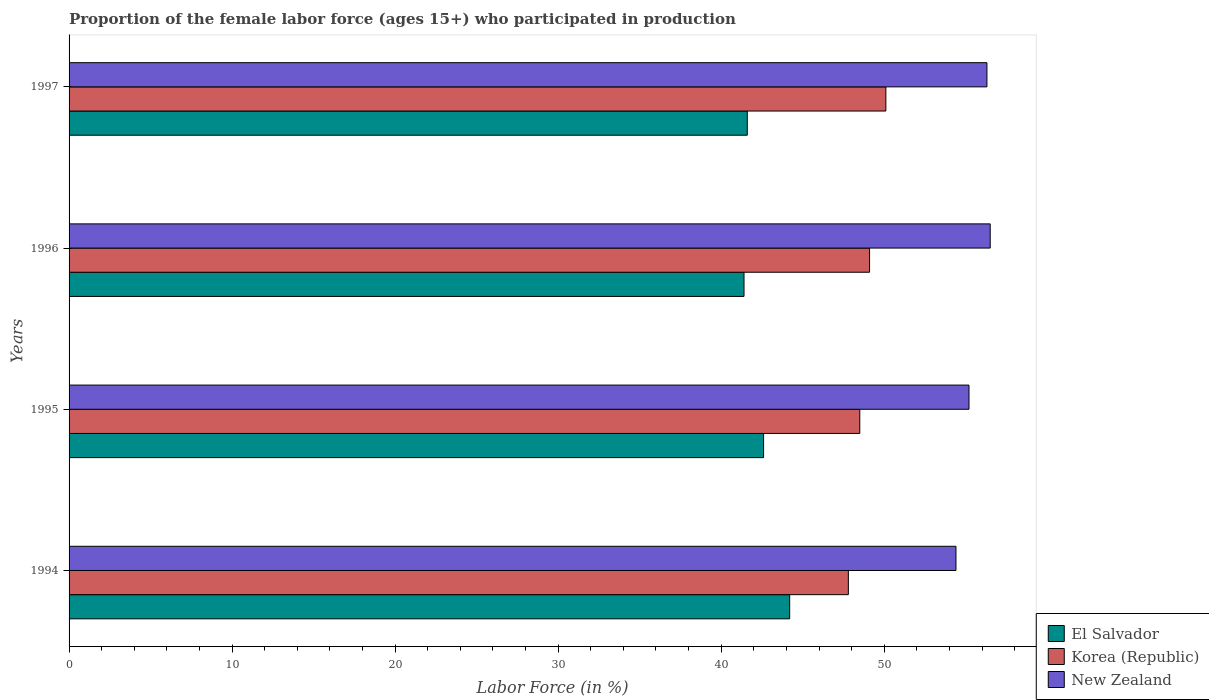How many groups of bars are there?
Make the answer very short. 4. What is the label of the 2nd group of bars from the top?
Provide a succinct answer. 1996. In how many cases, is the number of bars for a given year not equal to the number of legend labels?
Make the answer very short. 0. What is the proportion of the female labor force who participated in production in El Salvador in 1997?
Your answer should be compact. 41.6. Across all years, what is the maximum proportion of the female labor force who participated in production in New Zealand?
Provide a succinct answer. 56.5. Across all years, what is the minimum proportion of the female labor force who participated in production in El Salvador?
Keep it short and to the point. 41.4. In which year was the proportion of the female labor force who participated in production in El Salvador minimum?
Provide a succinct answer. 1996. What is the total proportion of the female labor force who participated in production in El Salvador in the graph?
Your answer should be compact. 169.8. What is the difference between the proportion of the female labor force who participated in production in El Salvador in 1995 and that in 1996?
Make the answer very short. 1.2. What is the difference between the proportion of the female labor force who participated in production in New Zealand in 1995 and the proportion of the female labor force who participated in production in Korea (Republic) in 1997?
Give a very brief answer. 5.1. What is the average proportion of the female labor force who participated in production in New Zealand per year?
Your answer should be very brief. 55.6. In the year 1996, what is the difference between the proportion of the female labor force who participated in production in Korea (Republic) and proportion of the female labor force who participated in production in New Zealand?
Ensure brevity in your answer.  -7.4. In how many years, is the proportion of the female labor force who participated in production in New Zealand greater than 20 %?
Provide a short and direct response. 4. What is the ratio of the proportion of the female labor force who participated in production in New Zealand in 1995 to that in 1996?
Your response must be concise. 0.98. What is the difference between the highest and the second highest proportion of the female labor force who participated in production in Korea (Republic)?
Offer a very short reply. 1. What is the difference between the highest and the lowest proportion of the female labor force who participated in production in New Zealand?
Ensure brevity in your answer.  2.1. In how many years, is the proportion of the female labor force who participated in production in Korea (Republic) greater than the average proportion of the female labor force who participated in production in Korea (Republic) taken over all years?
Your response must be concise. 2. What does the 3rd bar from the top in 1995 represents?
Provide a short and direct response. El Salvador. What does the 3rd bar from the bottom in 1995 represents?
Provide a succinct answer. New Zealand. Is it the case that in every year, the sum of the proportion of the female labor force who participated in production in Korea (Republic) and proportion of the female labor force who participated in production in New Zealand is greater than the proportion of the female labor force who participated in production in El Salvador?
Provide a short and direct response. Yes. Are all the bars in the graph horizontal?
Make the answer very short. Yes. How many years are there in the graph?
Your answer should be compact. 4. Are the values on the major ticks of X-axis written in scientific E-notation?
Provide a short and direct response. No. Does the graph contain grids?
Your answer should be compact. No. What is the title of the graph?
Your answer should be compact. Proportion of the female labor force (ages 15+) who participated in production. What is the label or title of the X-axis?
Give a very brief answer. Labor Force (in %). What is the Labor Force (in %) in El Salvador in 1994?
Give a very brief answer. 44.2. What is the Labor Force (in %) in Korea (Republic) in 1994?
Provide a succinct answer. 47.8. What is the Labor Force (in %) of New Zealand in 1994?
Ensure brevity in your answer.  54.4. What is the Labor Force (in %) in El Salvador in 1995?
Ensure brevity in your answer.  42.6. What is the Labor Force (in %) in Korea (Republic) in 1995?
Provide a short and direct response. 48.5. What is the Labor Force (in %) in New Zealand in 1995?
Your answer should be very brief. 55.2. What is the Labor Force (in %) of El Salvador in 1996?
Your response must be concise. 41.4. What is the Labor Force (in %) in Korea (Republic) in 1996?
Your response must be concise. 49.1. What is the Labor Force (in %) in New Zealand in 1996?
Offer a very short reply. 56.5. What is the Labor Force (in %) in El Salvador in 1997?
Provide a succinct answer. 41.6. What is the Labor Force (in %) of Korea (Republic) in 1997?
Give a very brief answer. 50.1. What is the Labor Force (in %) in New Zealand in 1997?
Your response must be concise. 56.3. Across all years, what is the maximum Labor Force (in %) in El Salvador?
Provide a succinct answer. 44.2. Across all years, what is the maximum Labor Force (in %) in Korea (Republic)?
Make the answer very short. 50.1. Across all years, what is the maximum Labor Force (in %) of New Zealand?
Your answer should be compact. 56.5. Across all years, what is the minimum Labor Force (in %) of El Salvador?
Ensure brevity in your answer.  41.4. Across all years, what is the minimum Labor Force (in %) of Korea (Republic)?
Offer a terse response. 47.8. Across all years, what is the minimum Labor Force (in %) of New Zealand?
Keep it short and to the point. 54.4. What is the total Labor Force (in %) in El Salvador in the graph?
Offer a terse response. 169.8. What is the total Labor Force (in %) of Korea (Republic) in the graph?
Your answer should be compact. 195.5. What is the total Labor Force (in %) in New Zealand in the graph?
Offer a terse response. 222.4. What is the difference between the Labor Force (in %) of New Zealand in 1994 and that in 1995?
Your response must be concise. -0.8. What is the difference between the Labor Force (in %) in El Salvador in 1994 and that in 1996?
Give a very brief answer. 2.8. What is the difference between the Labor Force (in %) of New Zealand in 1994 and that in 1996?
Give a very brief answer. -2.1. What is the difference between the Labor Force (in %) in El Salvador in 1994 and that in 1997?
Keep it short and to the point. 2.6. What is the difference between the Labor Force (in %) of Korea (Republic) in 1994 and that in 1997?
Keep it short and to the point. -2.3. What is the difference between the Labor Force (in %) in New Zealand in 1994 and that in 1997?
Provide a short and direct response. -1.9. What is the difference between the Labor Force (in %) in El Salvador in 1995 and that in 1997?
Your response must be concise. 1. What is the difference between the Labor Force (in %) of Korea (Republic) in 1995 and that in 1997?
Your answer should be very brief. -1.6. What is the difference between the Labor Force (in %) in New Zealand in 1995 and that in 1997?
Your answer should be very brief. -1.1. What is the difference between the Labor Force (in %) of El Salvador in 1996 and that in 1997?
Provide a succinct answer. -0.2. What is the difference between the Labor Force (in %) in Korea (Republic) in 1996 and that in 1997?
Your answer should be very brief. -1. What is the difference between the Labor Force (in %) of El Salvador in 1994 and the Labor Force (in %) of Korea (Republic) in 1995?
Keep it short and to the point. -4.3. What is the difference between the Labor Force (in %) of El Salvador in 1994 and the Labor Force (in %) of New Zealand in 1996?
Offer a terse response. -12.3. What is the difference between the Labor Force (in %) in Korea (Republic) in 1994 and the Labor Force (in %) in New Zealand in 1996?
Ensure brevity in your answer.  -8.7. What is the difference between the Labor Force (in %) in El Salvador in 1995 and the Labor Force (in %) in New Zealand in 1996?
Keep it short and to the point. -13.9. What is the difference between the Labor Force (in %) in El Salvador in 1995 and the Labor Force (in %) in New Zealand in 1997?
Your answer should be compact. -13.7. What is the difference between the Labor Force (in %) in Korea (Republic) in 1995 and the Labor Force (in %) in New Zealand in 1997?
Your answer should be compact. -7.8. What is the difference between the Labor Force (in %) of El Salvador in 1996 and the Labor Force (in %) of New Zealand in 1997?
Offer a terse response. -14.9. What is the average Labor Force (in %) in El Salvador per year?
Your response must be concise. 42.45. What is the average Labor Force (in %) of Korea (Republic) per year?
Keep it short and to the point. 48.88. What is the average Labor Force (in %) of New Zealand per year?
Give a very brief answer. 55.6. In the year 1995, what is the difference between the Labor Force (in %) in El Salvador and Labor Force (in %) in New Zealand?
Your answer should be very brief. -12.6. In the year 1996, what is the difference between the Labor Force (in %) in El Salvador and Labor Force (in %) in New Zealand?
Provide a short and direct response. -15.1. In the year 1996, what is the difference between the Labor Force (in %) in Korea (Republic) and Labor Force (in %) in New Zealand?
Offer a very short reply. -7.4. In the year 1997, what is the difference between the Labor Force (in %) of El Salvador and Labor Force (in %) of New Zealand?
Your response must be concise. -14.7. In the year 1997, what is the difference between the Labor Force (in %) of Korea (Republic) and Labor Force (in %) of New Zealand?
Your answer should be very brief. -6.2. What is the ratio of the Labor Force (in %) of El Salvador in 1994 to that in 1995?
Provide a succinct answer. 1.04. What is the ratio of the Labor Force (in %) in Korea (Republic) in 1994 to that in 1995?
Offer a very short reply. 0.99. What is the ratio of the Labor Force (in %) in New Zealand in 1994 to that in 1995?
Make the answer very short. 0.99. What is the ratio of the Labor Force (in %) of El Salvador in 1994 to that in 1996?
Make the answer very short. 1.07. What is the ratio of the Labor Force (in %) of Korea (Republic) in 1994 to that in 1996?
Give a very brief answer. 0.97. What is the ratio of the Labor Force (in %) in New Zealand in 1994 to that in 1996?
Provide a succinct answer. 0.96. What is the ratio of the Labor Force (in %) of El Salvador in 1994 to that in 1997?
Your answer should be compact. 1.06. What is the ratio of the Labor Force (in %) of Korea (Republic) in 1994 to that in 1997?
Ensure brevity in your answer.  0.95. What is the ratio of the Labor Force (in %) of New Zealand in 1994 to that in 1997?
Your answer should be compact. 0.97. What is the ratio of the Labor Force (in %) in Korea (Republic) in 1995 to that in 1996?
Offer a very short reply. 0.99. What is the ratio of the Labor Force (in %) of El Salvador in 1995 to that in 1997?
Your answer should be very brief. 1.02. What is the ratio of the Labor Force (in %) in Korea (Republic) in 1995 to that in 1997?
Keep it short and to the point. 0.97. What is the ratio of the Labor Force (in %) of New Zealand in 1995 to that in 1997?
Offer a very short reply. 0.98. What is the ratio of the Labor Force (in %) in Korea (Republic) in 1996 to that in 1997?
Your response must be concise. 0.98. What is the ratio of the Labor Force (in %) in New Zealand in 1996 to that in 1997?
Your answer should be compact. 1. What is the difference between the highest and the second highest Labor Force (in %) in El Salvador?
Your answer should be very brief. 1.6. What is the difference between the highest and the lowest Labor Force (in %) of New Zealand?
Your answer should be compact. 2.1. 